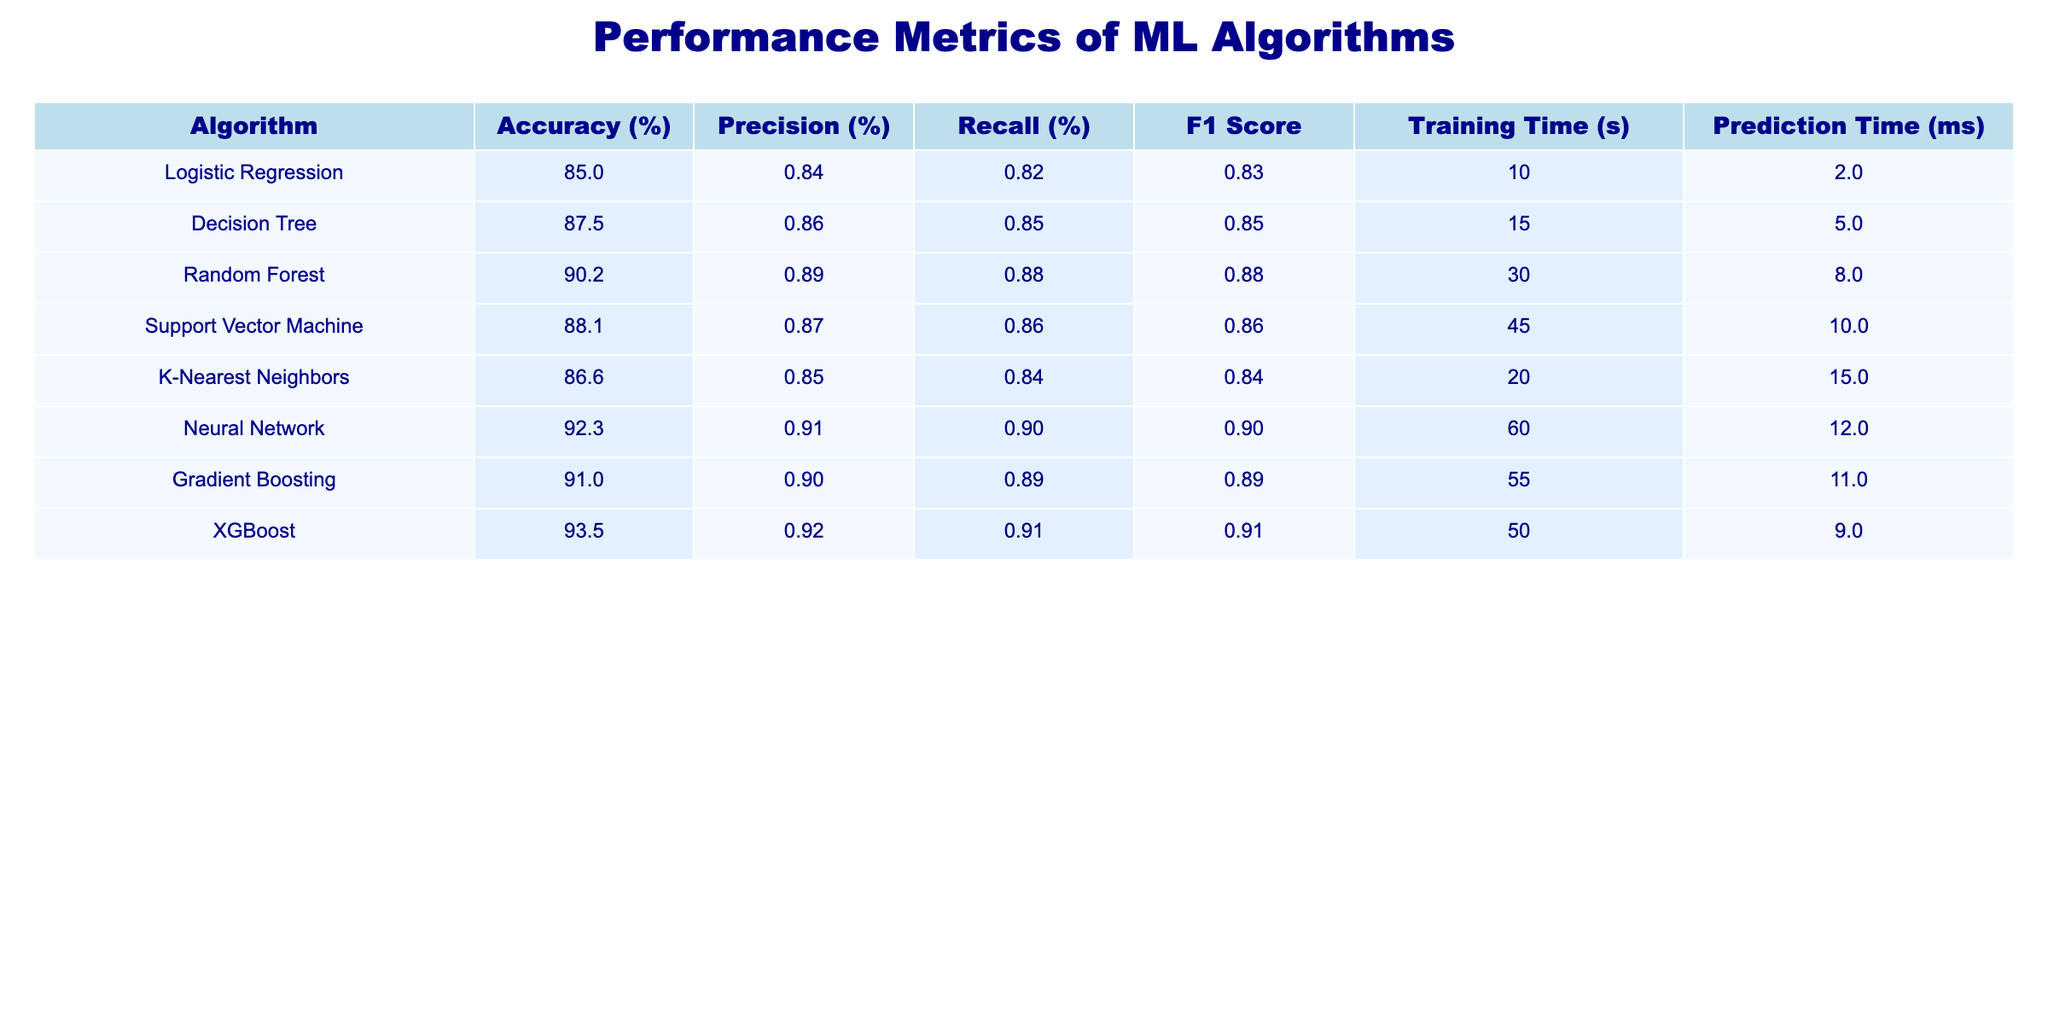What is the accuracy of the Neural Network algorithm? The accuracy value for the Neural Network algorithm is directly visible in the table under the Accuracy (%) column. It shows a value of 92.3%.
Answer: 92.3% Which algorithm has the highest Precision? By reviewing the Precision (%) column, we see the highest value is associated with the XGBoost algorithm, which has a Precision of 0.92.
Answer: XGBoost What is the average F1 Score of all algorithms listed? To calculate the average F1 Score, we first sum all the F1 Scores: 0.83 + 0.85 + 0.88 + 0.86 + 0.84 + 0.90 + 0.89 + 0.91 = 6.96. Then, divide by the number of algorithms, which is 8: 6.96/8 = 0.87.
Answer: 0.87 Is the Training Time of Random Forest greater than that of Support Vector Machine? Looking at the Training Time (s) column, Random Forest has a Training Time of 30 seconds and Support Vector Machine has 45 seconds. Since 30 is less than 45, the statement is false.
Answer: No Which algorithm has the lowest Recall, and what is its value? By inspecting the Recall (%) column, we notice that the Logistic Regression algorithm has the lowest Recall value at 0.82.
Answer: Logistic Regression, 0.82 What is the difference in Prediction Time between XGBoost and Decision Tree algorithms? The Prediction Time (ms) for XGBoost is 9 ms, and for Decision Tree, it is 5 ms. To find the difference, we subtract the Prediction Time of Decision Tree from that of XGBoost: 9 - 5 = 4 ms.
Answer: 4 ms Does the Support Vector Machine algorithm have a higher accuracy than K-Nearest Neighbors? In the Accuracy (%) column, Support Vector Machine has an accuracy of 88.1%, and K-Nearest Neighbors has an accuracy of 86.6%. Since 88.1 is greater than 86.6, the statement is true.
Answer: Yes What is the sum of all Training Times for the listed algorithms? We sum the Training Times: 10 + 15 + 30 + 45 + 20 + 60 + 55 + 50 = 285 seconds. This gives us the total Training Time for all algorithms combined.
Answer: 285 seconds 